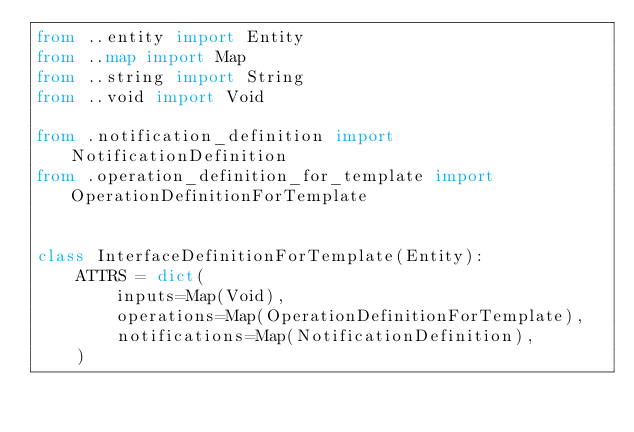<code> <loc_0><loc_0><loc_500><loc_500><_Python_>from ..entity import Entity
from ..map import Map
from ..string import String
from ..void import Void

from .notification_definition import NotificationDefinition
from .operation_definition_for_template import OperationDefinitionForTemplate


class InterfaceDefinitionForTemplate(Entity):
    ATTRS = dict(
        inputs=Map(Void),
        operations=Map(OperationDefinitionForTemplate),
        notifications=Map(NotificationDefinition),
    )
</code> 